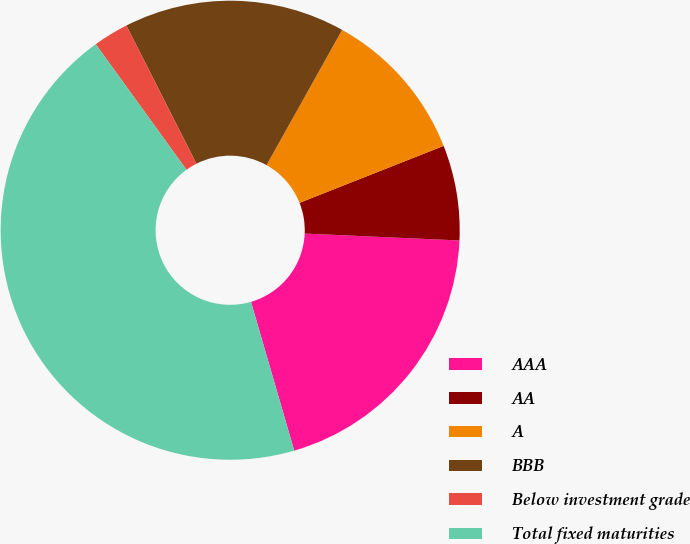Convert chart to OTSL. <chart><loc_0><loc_0><loc_500><loc_500><pie_chart><fcel>AAA<fcel>AA<fcel>A<fcel>BBB<fcel>Below investment grade<fcel>Total fixed maturities<nl><fcel>19.79%<fcel>6.7%<fcel>10.9%<fcel>15.58%<fcel>2.49%<fcel>44.54%<nl></chart> 